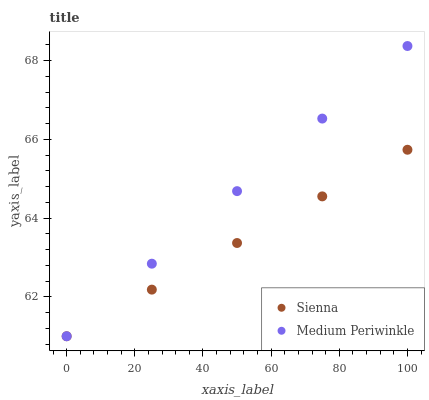Does Sienna have the minimum area under the curve?
Answer yes or no. Yes. Does Medium Periwinkle have the maximum area under the curve?
Answer yes or no. Yes. Does Medium Periwinkle have the minimum area under the curve?
Answer yes or no. No. Is Medium Periwinkle the smoothest?
Answer yes or no. Yes. Is Sienna the roughest?
Answer yes or no. Yes. Is Medium Periwinkle the roughest?
Answer yes or no. No. Does Sienna have the lowest value?
Answer yes or no. Yes. Does Medium Periwinkle have the highest value?
Answer yes or no. Yes. Does Sienna intersect Medium Periwinkle?
Answer yes or no. Yes. Is Sienna less than Medium Periwinkle?
Answer yes or no. No. Is Sienna greater than Medium Periwinkle?
Answer yes or no. No. 